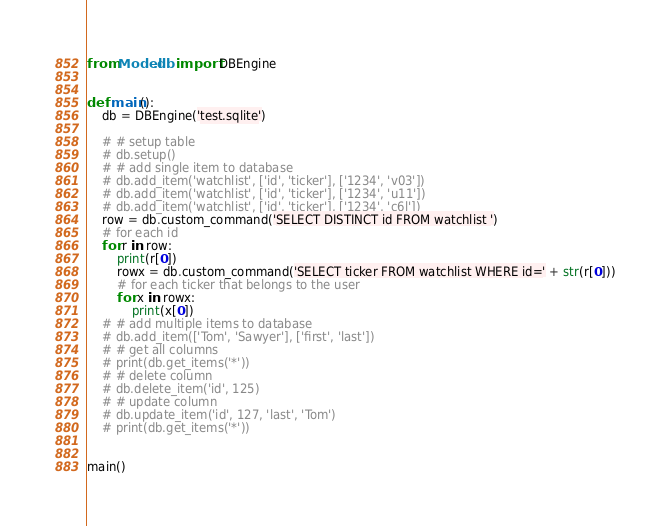<code> <loc_0><loc_0><loc_500><loc_500><_Python_>from Model.db import DBEngine


def main():
    db = DBEngine('test.sqlite')

    # # setup table
    # db.setup()
    # # add single item to database
    # db.add_item('watchlist', ['id', 'ticker'], ['1234', 'v03'])
    # db.add_item('watchlist', ['id', 'ticker'], ['1234', 'u11'])
    # db.add_item('watchlist', ['id', 'ticker'], ['1234', 'c6l'])
    row = db.custom_command('SELECT DISTINCT id FROM watchlist ')
    # for each id
    for r in row:
        print(r[0])
        rowx = db.custom_command('SELECT ticker FROM watchlist WHERE id=' + str(r[0]))
        # for each ticker that belongs to the user
        for x in rowx:
            print(x[0])
    # # add multiple items to database
    # db.add_item(['Tom', 'Sawyer'], ['first', 'last'])
    # # get all columns
    # print(db.get_items('*'))
    # # delete column
    # db.delete_item('id', 125)
    # # update column
    # db.update_item('id', 127, 'last', 'Tom')
    # print(db.get_items('*'))


main()</code> 